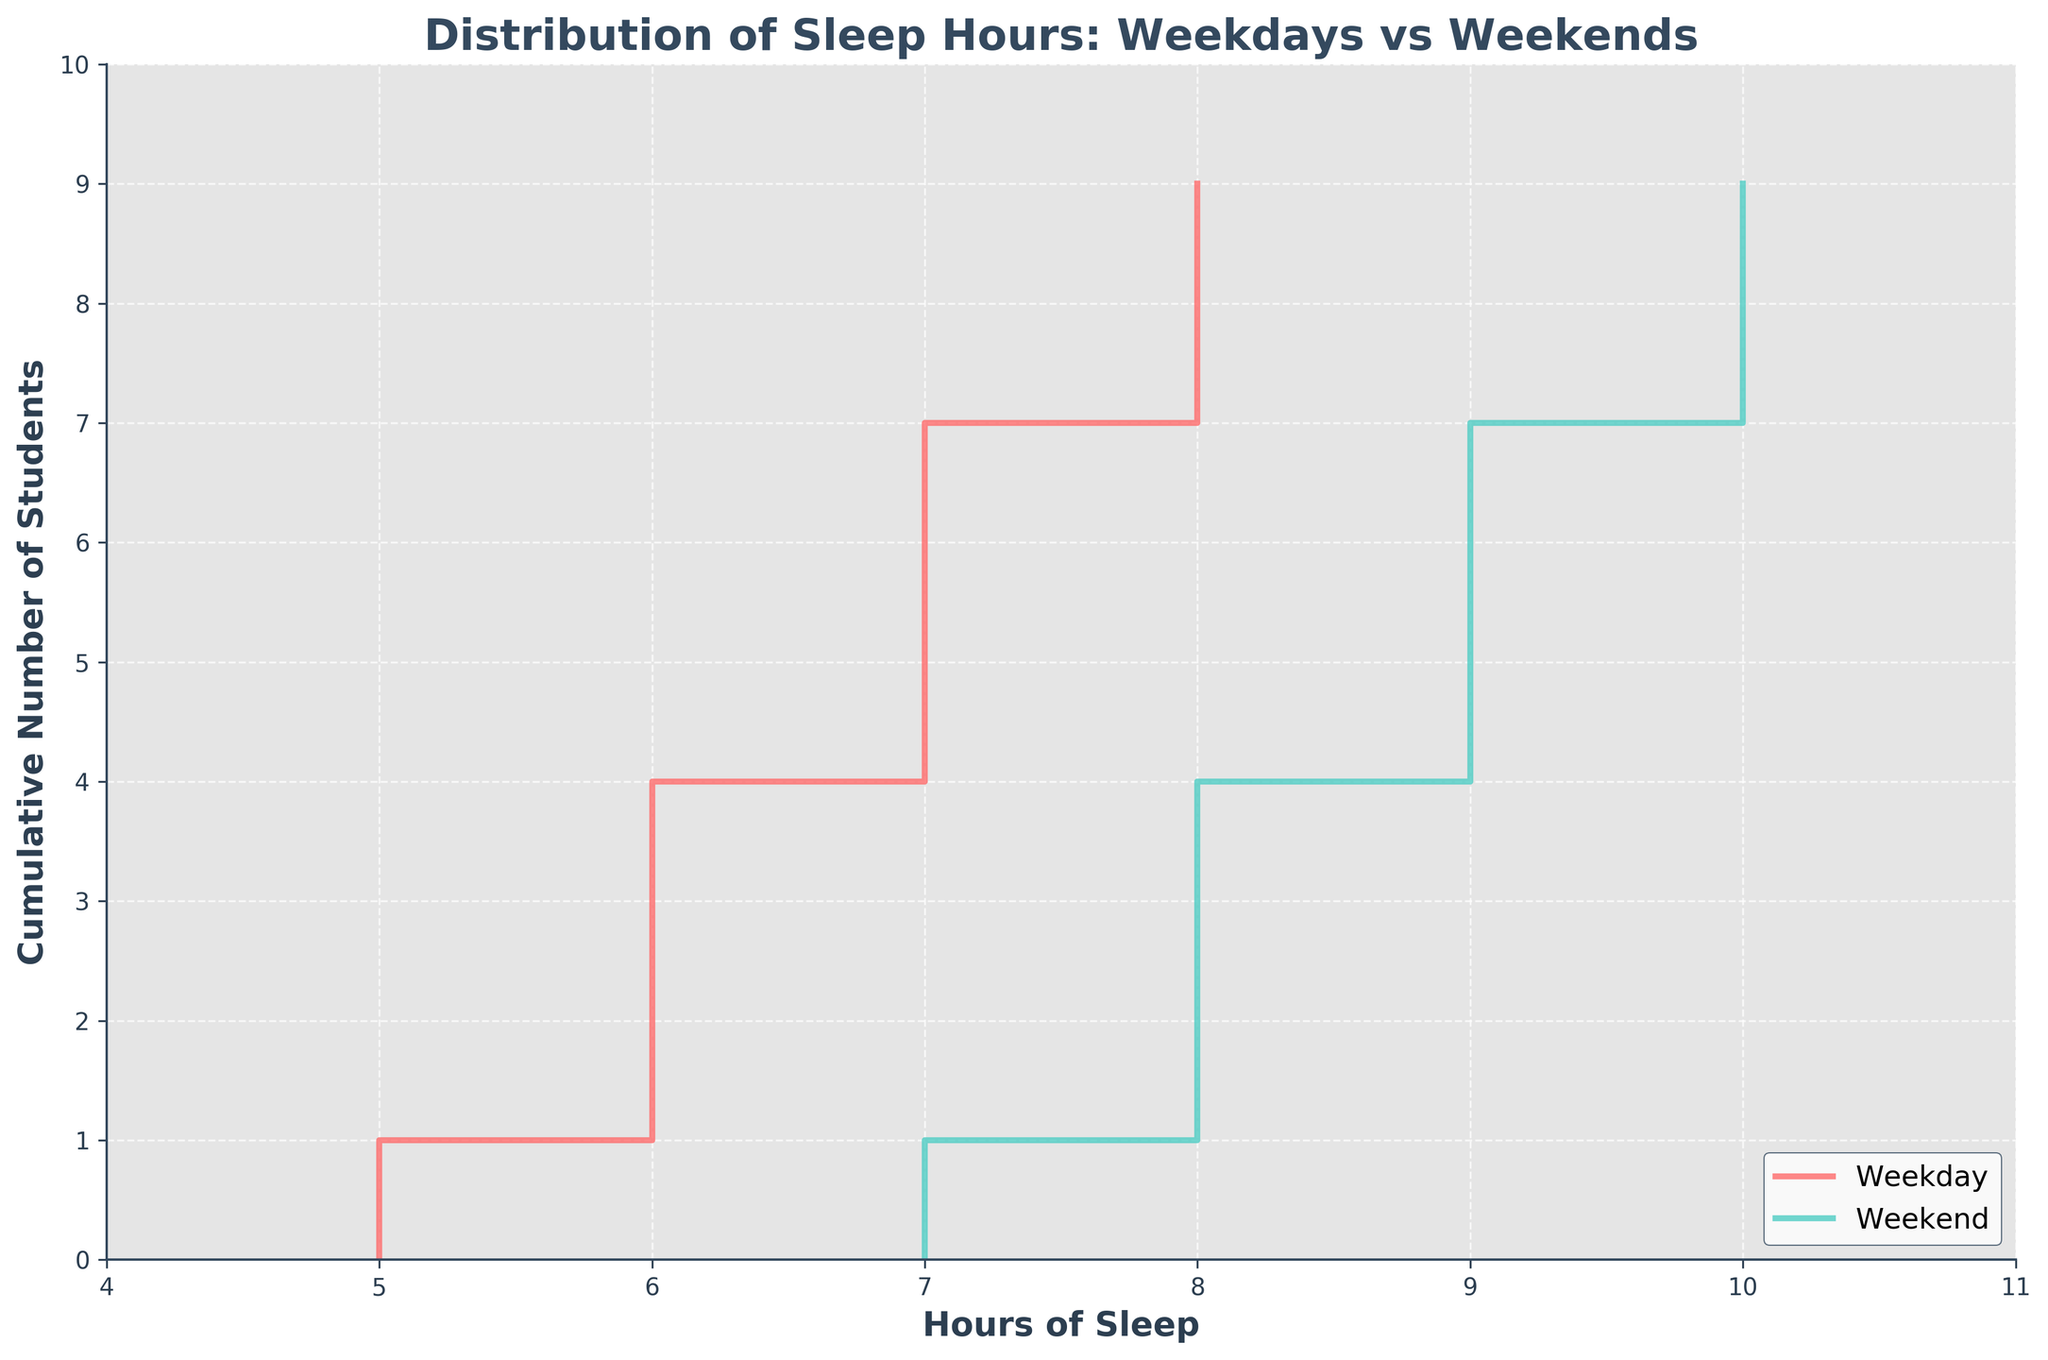What is the title of the figure? The title is usually placed above the plot. In this case, it states "Distribution of Sleep Hours: Weekdays vs Weekends".
Answer: Distribution of Sleep Hours: Weekdays vs Weekends Which color represents weekend sleep hours in the plot? The stair plot uses color to distinguish between weekdays and weekends. The legend indicates that weekends are represented by the color cyan.
Answer: Cyan How many students have 7 hours of sleep on weekdays? By reading the stair step for weekdays at the 7-hour mark on the x-axis, you can see the cumulative number of students just before and after this point. The step increases at this point, indicating 4 students have 7 hours of sleep.
Answer: 4 What is the maximum number of hours slept on weekends according to the plot? To find the maximum number of hours, you look at the highest point on the sleep hours axis for weekends. The plot shows the maximum hours of sleep on weekends is 10.
Answer: 10 Which day type shows a higher cumulative number of students at 7 hours of sleep? At 7 hours of sleep, we compare the cumulative number of students for weekdays and weekends by checking the step height on both lines. Weekdays have a higher cumulative number of students than weekends at the 7-hour mark.
Answer: Weekday What is the range of hours of sleep observed on weekdays? The range is determined by subtracting the minimum value on the x-axis from the maximum value for weekdays. The minimum is 5 and the maximum is 8, giving a range of 8 - 5 = 3 hours.
Answer: 3 hours Is there a gap in sleep hours where no students have reported sleeping that amount on weekdays? By following the step plot for weekdays, we look for sections where the steps do not rise. There is no step between 5 and 6 hours on weekdays, indicating no students reported sleeping for exactly 5.5 or 6.5 hours.
Answer: Yes On which day type do students get more sleep on average? To determine the average, we observe the overall distribution shape of both plots. The weekend stair plot shifts right (towards higher hours) indicating that, overall, students sleep more on weekends.
Answer: Weekend At how many hours of sleep do the weekday and weekend lines intersect? The intersection point can be found by locating where both lines meet at the same x (hours) and y (cumulative number of students) coordinates. They intersect at 7 hours of sleep.
Answer: 7 hours 